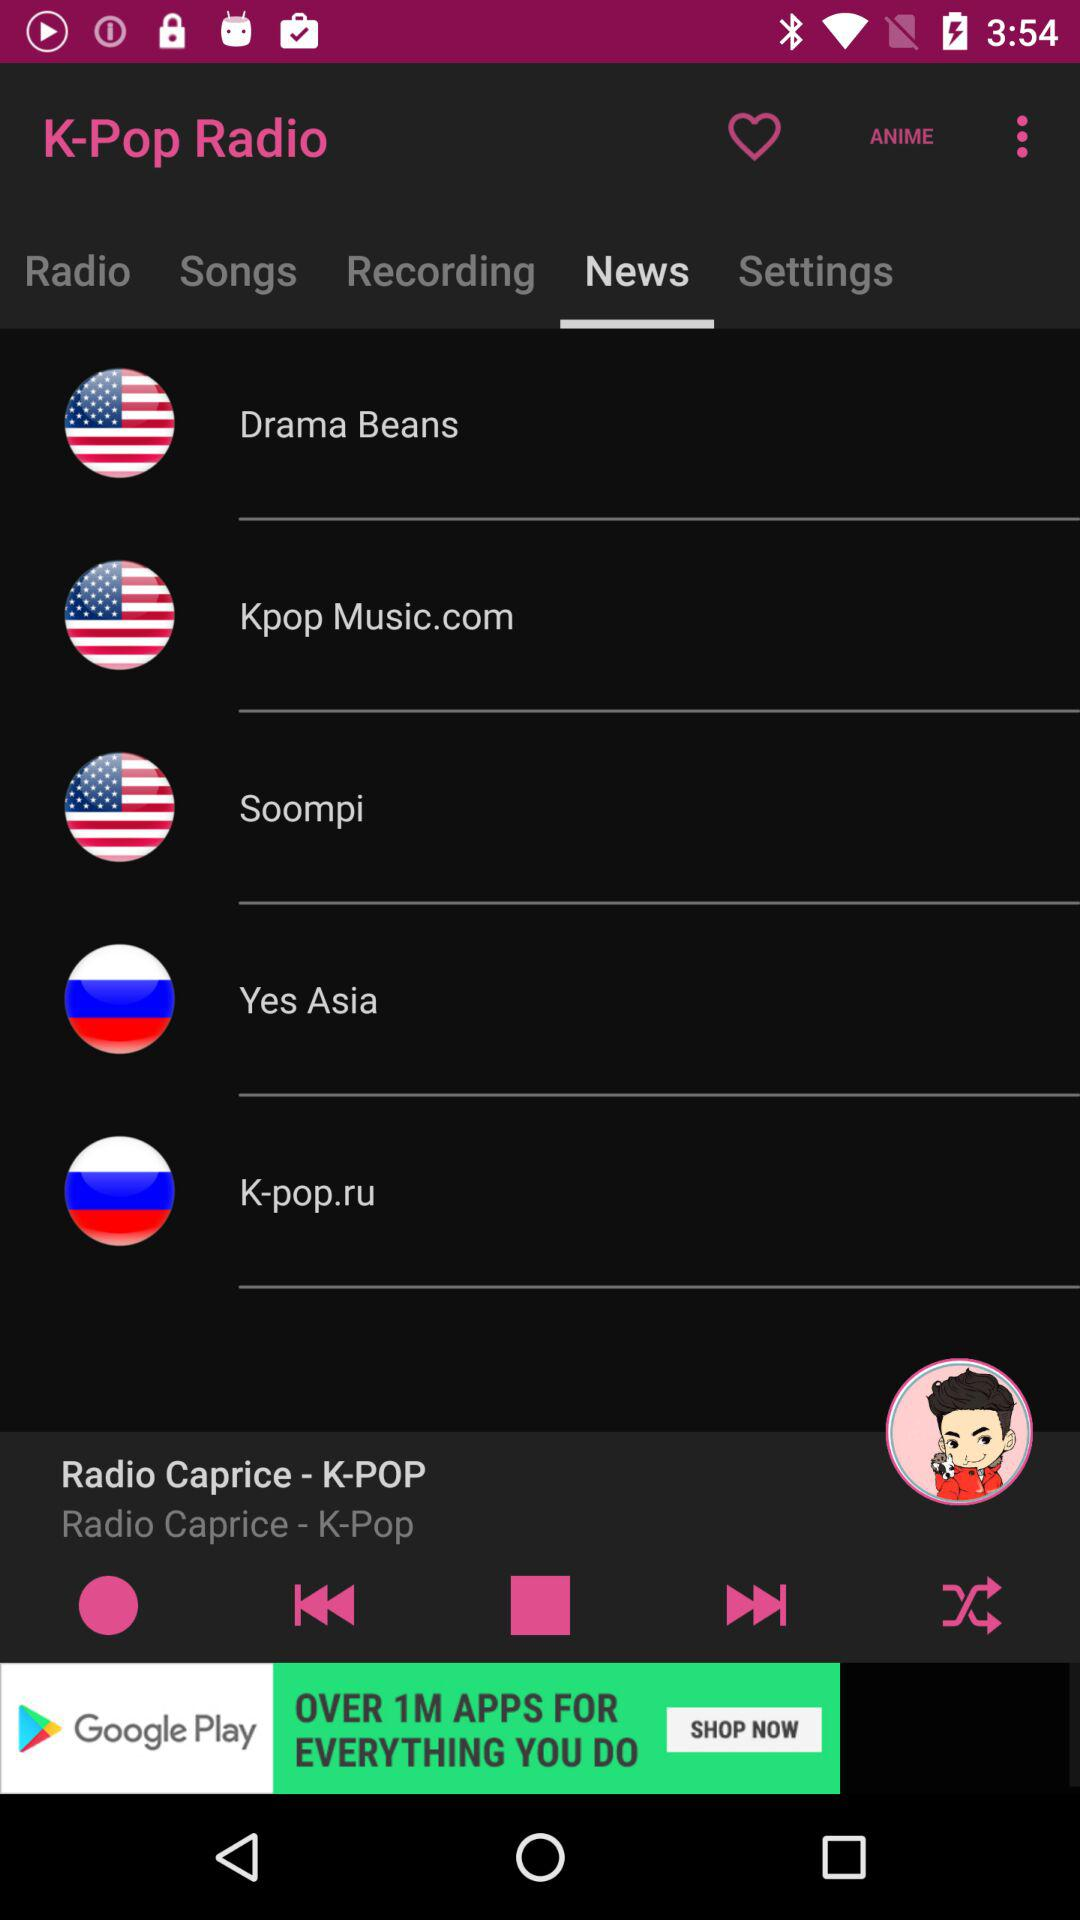Which tab is open? The open tab is "News". 